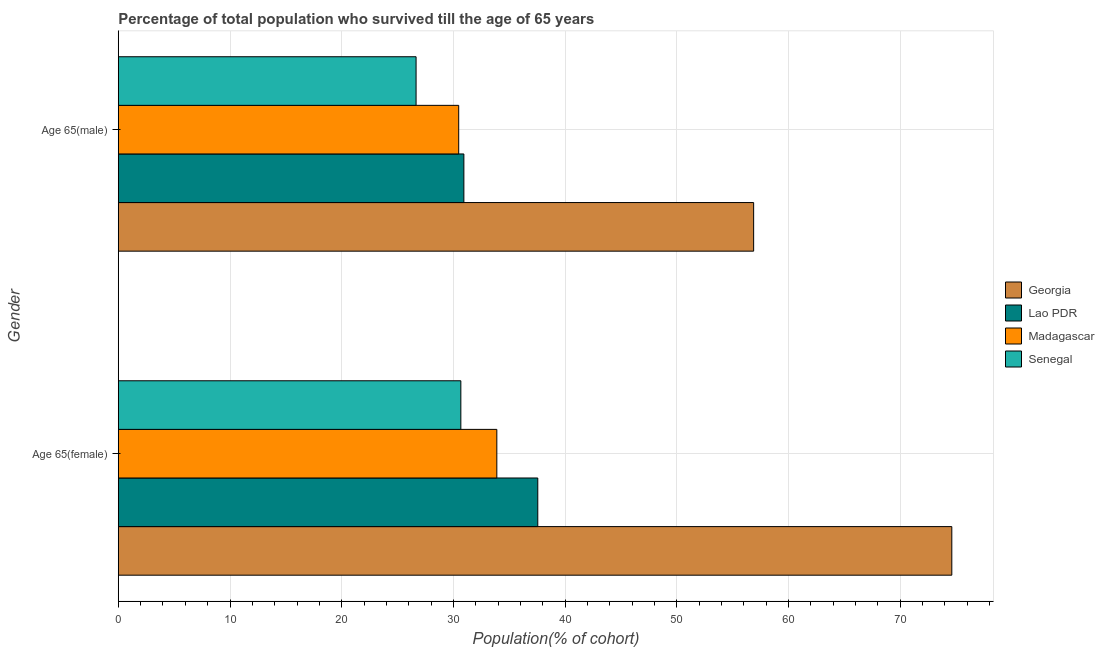Are the number of bars on each tick of the Y-axis equal?
Ensure brevity in your answer.  Yes. How many bars are there on the 1st tick from the top?
Your answer should be very brief. 4. What is the label of the 2nd group of bars from the top?
Your answer should be very brief. Age 65(female). What is the percentage of female population who survived till age of 65 in Lao PDR?
Provide a short and direct response. 37.55. Across all countries, what is the maximum percentage of male population who survived till age of 65?
Your response must be concise. 56.88. Across all countries, what is the minimum percentage of female population who survived till age of 65?
Make the answer very short. 30.66. In which country was the percentage of female population who survived till age of 65 maximum?
Offer a very short reply. Georgia. In which country was the percentage of female population who survived till age of 65 minimum?
Ensure brevity in your answer.  Senegal. What is the total percentage of female population who survived till age of 65 in the graph?
Your response must be concise. 176.72. What is the difference between the percentage of female population who survived till age of 65 in Georgia and that in Madagascar?
Provide a succinct answer. 40.73. What is the difference between the percentage of female population who survived till age of 65 in Lao PDR and the percentage of male population who survived till age of 65 in Senegal?
Give a very brief answer. 10.89. What is the average percentage of female population who survived till age of 65 per country?
Your answer should be compact. 44.18. What is the difference between the percentage of female population who survived till age of 65 and percentage of male population who survived till age of 65 in Lao PDR?
Ensure brevity in your answer.  6.62. What is the ratio of the percentage of male population who survived till age of 65 in Madagascar to that in Georgia?
Provide a short and direct response. 0.54. In how many countries, is the percentage of male population who survived till age of 65 greater than the average percentage of male population who survived till age of 65 taken over all countries?
Provide a short and direct response. 1. What does the 3rd bar from the top in Age 65(male) represents?
Make the answer very short. Lao PDR. What does the 2nd bar from the bottom in Age 65(female) represents?
Provide a short and direct response. Lao PDR. How many bars are there?
Make the answer very short. 8. Are the values on the major ticks of X-axis written in scientific E-notation?
Your answer should be compact. No. Does the graph contain grids?
Make the answer very short. Yes. Where does the legend appear in the graph?
Provide a short and direct response. Center right. What is the title of the graph?
Your response must be concise. Percentage of total population who survived till the age of 65 years. What is the label or title of the X-axis?
Your response must be concise. Population(% of cohort). What is the label or title of the Y-axis?
Your answer should be very brief. Gender. What is the Population(% of cohort) of Georgia in Age 65(female)?
Offer a very short reply. 74.62. What is the Population(% of cohort) in Lao PDR in Age 65(female)?
Offer a very short reply. 37.55. What is the Population(% of cohort) of Madagascar in Age 65(female)?
Provide a short and direct response. 33.89. What is the Population(% of cohort) in Senegal in Age 65(female)?
Your response must be concise. 30.66. What is the Population(% of cohort) of Georgia in Age 65(male)?
Give a very brief answer. 56.88. What is the Population(% of cohort) of Lao PDR in Age 65(male)?
Give a very brief answer. 30.94. What is the Population(% of cohort) in Madagascar in Age 65(male)?
Give a very brief answer. 30.47. What is the Population(% of cohort) in Senegal in Age 65(male)?
Provide a short and direct response. 26.66. Across all Gender, what is the maximum Population(% of cohort) of Georgia?
Your response must be concise. 74.62. Across all Gender, what is the maximum Population(% of cohort) of Lao PDR?
Keep it short and to the point. 37.55. Across all Gender, what is the maximum Population(% of cohort) in Madagascar?
Provide a succinct answer. 33.89. Across all Gender, what is the maximum Population(% of cohort) in Senegal?
Your answer should be compact. 30.66. Across all Gender, what is the minimum Population(% of cohort) in Georgia?
Your response must be concise. 56.88. Across all Gender, what is the minimum Population(% of cohort) in Lao PDR?
Your response must be concise. 30.94. Across all Gender, what is the minimum Population(% of cohort) in Madagascar?
Offer a very short reply. 30.47. Across all Gender, what is the minimum Population(% of cohort) in Senegal?
Provide a short and direct response. 26.66. What is the total Population(% of cohort) of Georgia in the graph?
Give a very brief answer. 131.49. What is the total Population(% of cohort) of Lao PDR in the graph?
Your response must be concise. 68.49. What is the total Population(% of cohort) of Madagascar in the graph?
Offer a terse response. 64.36. What is the total Population(% of cohort) of Senegal in the graph?
Ensure brevity in your answer.  57.32. What is the difference between the Population(% of cohort) of Georgia in Age 65(female) and that in Age 65(male)?
Offer a very short reply. 17.74. What is the difference between the Population(% of cohort) in Lao PDR in Age 65(female) and that in Age 65(male)?
Provide a succinct answer. 6.62. What is the difference between the Population(% of cohort) of Madagascar in Age 65(female) and that in Age 65(male)?
Make the answer very short. 3.41. What is the difference between the Population(% of cohort) in Senegal in Age 65(female) and that in Age 65(male)?
Keep it short and to the point. 4.01. What is the difference between the Population(% of cohort) in Georgia in Age 65(female) and the Population(% of cohort) in Lao PDR in Age 65(male)?
Keep it short and to the point. 43.68. What is the difference between the Population(% of cohort) in Georgia in Age 65(female) and the Population(% of cohort) in Madagascar in Age 65(male)?
Your answer should be compact. 44.14. What is the difference between the Population(% of cohort) of Georgia in Age 65(female) and the Population(% of cohort) of Senegal in Age 65(male)?
Provide a succinct answer. 47.96. What is the difference between the Population(% of cohort) in Lao PDR in Age 65(female) and the Population(% of cohort) in Madagascar in Age 65(male)?
Offer a terse response. 7.08. What is the difference between the Population(% of cohort) in Lao PDR in Age 65(female) and the Population(% of cohort) in Senegal in Age 65(male)?
Offer a terse response. 10.89. What is the difference between the Population(% of cohort) in Madagascar in Age 65(female) and the Population(% of cohort) in Senegal in Age 65(male)?
Give a very brief answer. 7.23. What is the average Population(% of cohort) in Georgia per Gender?
Offer a terse response. 65.75. What is the average Population(% of cohort) of Lao PDR per Gender?
Give a very brief answer. 34.24. What is the average Population(% of cohort) in Madagascar per Gender?
Provide a short and direct response. 32.18. What is the average Population(% of cohort) in Senegal per Gender?
Your response must be concise. 28.66. What is the difference between the Population(% of cohort) in Georgia and Population(% of cohort) in Lao PDR in Age 65(female)?
Provide a succinct answer. 37.06. What is the difference between the Population(% of cohort) in Georgia and Population(% of cohort) in Madagascar in Age 65(female)?
Your answer should be very brief. 40.73. What is the difference between the Population(% of cohort) of Georgia and Population(% of cohort) of Senegal in Age 65(female)?
Give a very brief answer. 43.95. What is the difference between the Population(% of cohort) of Lao PDR and Population(% of cohort) of Madagascar in Age 65(female)?
Provide a short and direct response. 3.67. What is the difference between the Population(% of cohort) of Lao PDR and Population(% of cohort) of Senegal in Age 65(female)?
Ensure brevity in your answer.  6.89. What is the difference between the Population(% of cohort) of Madagascar and Population(% of cohort) of Senegal in Age 65(female)?
Your response must be concise. 3.22. What is the difference between the Population(% of cohort) of Georgia and Population(% of cohort) of Lao PDR in Age 65(male)?
Your response must be concise. 25.94. What is the difference between the Population(% of cohort) of Georgia and Population(% of cohort) of Madagascar in Age 65(male)?
Make the answer very short. 26.4. What is the difference between the Population(% of cohort) of Georgia and Population(% of cohort) of Senegal in Age 65(male)?
Offer a terse response. 30.22. What is the difference between the Population(% of cohort) in Lao PDR and Population(% of cohort) in Madagascar in Age 65(male)?
Your answer should be compact. 0.46. What is the difference between the Population(% of cohort) in Lao PDR and Population(% of cohort) in Senegal in Age 65(male)?
Make the answer very short. 4.28. What is the difference between the Population(% of cohort) of Madagascar and Population(% of cohort) of Senegal in Age 65(male)?
Your response must be concise. 3.82. What is the ratio of the Population(% of cohort) of Georgia in Age 65(female) to that in Age 65(male)?
Your answer should be compact. 1.31. What is the ratio of the Population(% of cohort) in Lao PDR in Age 65(female) to that in Age 65(male)?
Offer a very short reply. 1.21. What is the ratio of the Population(% of cohort) of Madagascar in Age 65(female) to that in Age 65(male)?
Keep it short and to the point. 1.11. What is the ratio of the Population(% of cohort) of Senegal in Age 65(female) to that in Age 65(male)?
Ensure brevity in your answer.  1.15. What is the difference between the highest and the second highest Population(% of cohort) of Georgia?
Your answer should be compact. 17.74. What is the difference between the highest and the second highest Population(% of cohort) of Lao PDR?
Offer a terse response. 6.62. What is the difference between the highest and the second highest Population(% of cohort) of Madagascar?
Your response must be concise. 3.41. What is the difference between the highest and the second highest Population(% of cohort) of Senegal?
Keep it short and to the point. 4.01. What is the difference between the highest and the lowest Population(% of cohort) in Georgia?
Offer a very short reply. 17.74. What is the difference between the highest and the lowest Population(% of cohort) in Lao PDR?
Make the answer very short. 6.62. What is the difference between the highest and the lowest Population(% of cohort) in Madagascar?
Give a very brief answer. 3.41. What is the difference between the highest and the lowest Population(% of cohort) of Senegal?
Make the answer very short. 4.01. 